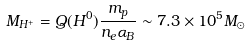Convert formula to latex. <formula><loc_0><loc_0><loc_500><loc_500>M _ { H ^ { + } } = Q ( H ^ { 0 } ) \frac { m _ { p } } { n _ { e } \alpha _ { B } } \sim 7 . 3 \times 1 0 ^ { 5 } M _ { \odot }</formula> 